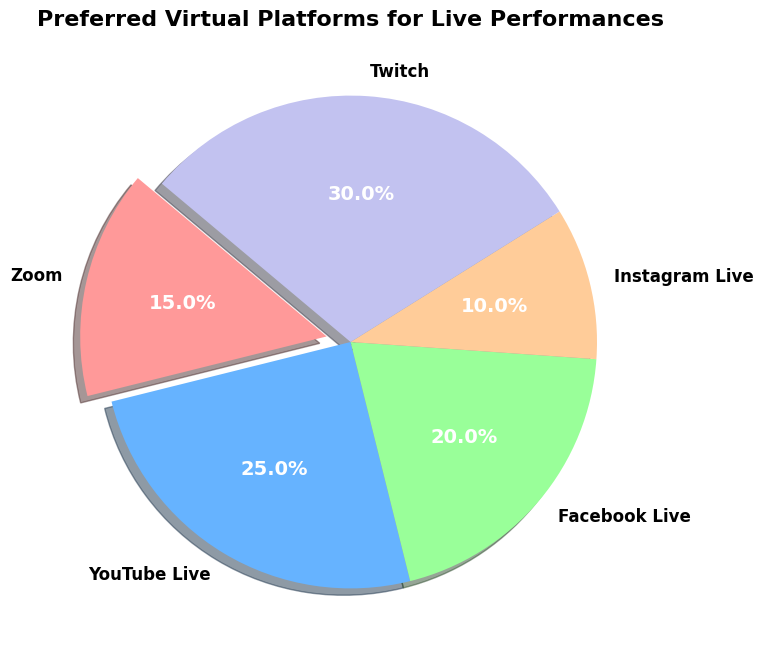Which platform is the most preferred for live performances? The platform with the largest percentage on the pie chart is Twitch with 30%.
Answer: Twitch Which platform has the smallest share of preference for live performances? The platform with the smallest percentage on the pie chart is Instagram Live with 10%.
Answer: Instagram Live How much more preferred is Twitch compared to Instagram Live? Twitch has 30% while Instagram Live has 10%. The difference is 30% - 10% = 20%.
Answer: 20% What is the combined percentage for YouTube Live and Facebook Live? YouTube Live has 25% and Facebook Live has 20%. The combined percentage is 25% + 20% = 45%.
Answer: 45% Which platforms together account for more than half of the preferences? Twitch (30%) and YouTube Live (25%) together account for 30% + 25% = 55%, which is more than half.
Answer: Twitch and YouTube Live What is the difference in preference percentages between Facebook Live and Zoom? Facebook Live has 20% and Zoom has 15%. The difference is 20% - 15% = 5%.
Answer: 5% Which platform slice is "exploded" or highlighted in the pie chart? The slice for Zoom is exploded for emphasis.
Answer: Zoom If Twitch's preference increased by 10 percentage points, what would be its new percentage? Twitch currently has 30%. An increase of 10 percentage points would make it 30% + 10% = 40%.
Answer: 40% Which platform shares a similar preference level with Facebook Live? YouTube Live has a similar percentage, with YouTube Live at 25% and Facebook Live at 20%.
Answer: YouTube Live How much less preferred is Zoom compared to the most preferred platform? The most preferred platform, Twitch, has 30%, while Zoom has 15%. The preference difference is 30% - 15% = 15%.
Answer: 15% 